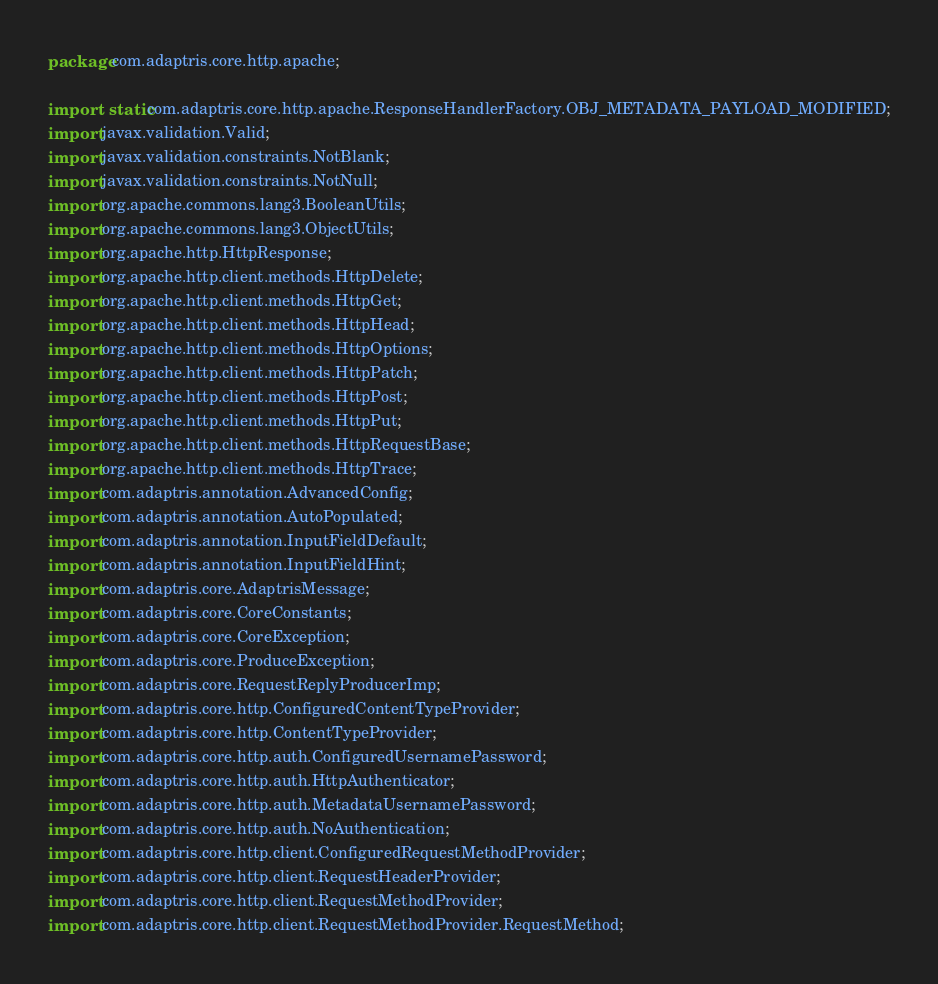Convert code to text. <code><loc_0><loc_0><loc_500><loc_500><_Java_>package com.adaptris.core.http.apache;

import static com.adaptris.core.http.apache.ResponseHandlerFactory.OBJ_METADATA_PAYLOAD_MODIFIED;
import javax.validation.Valid;
import javax.validation.constraints.NotBlank;
import javax.validation.constraints.NotNull;
import org.apache.commons.lang3.BooleanUtils;
import org.apache.commons.lang3.ObjectUtils;
import org.apache.http.HttpResponse;
import org.apache.http.client.methods.HttpDelete;
import org.apache.http.client.methods.HttpGet;
import org.apache.http.client.methods.HttpHead;
import org.apache.http.client.methods.HttpOptions;
import org.apache.http.client.methods.HttpPatch;
import org.apache.http.client.methods.HttpPost;
import org.apache.http.client.methods.HttpPut;
import org.apache.http.client.methods.HttpRequestBase;
import org.apache.http.client.methods.HttpTrace;
import com.adaptris.annotation.AdvancedConfig;
import com.adaptris.annotation.AutoPopulated;
import com.adaptris.annotation.InputFieldDefault;
import com.adaptris.annotation.InputFieldHint;
import com.adaptris.core.AdaptrisMessage;
import com.adaptris.core.CoreConstants;
import com.adaptris.core.CoreException;
import com.adaptris.core.ProduceException;
import com.adaptris.core.RequestReplyProducerImp;
import com.adaptris.core.http.ConfiguredContentTypeProvider;
import com.adaptris.core.http.ContentTypeProvider;
import com.adaptris.core.http.auth.ConfiguredUsernamePassword;
import com.adaptris.core.http.auth.HttpAuthenticator;
import com.adaptris.core.http.auth.MetadataUsernamePassword;
import com.adaptris.core.http.auth.NoAuthentication;
import com.adaptris.core.http.client.ConfiguredRequestMethodProvider;
import com.adaptris.core.http.client.RequestHeaderProvider;
import com.adaptris.core.http.client.RequestMethodProvider;
import com.adaptris.core.http.client.RequestMethodProvider.RequestMethod;</code> 